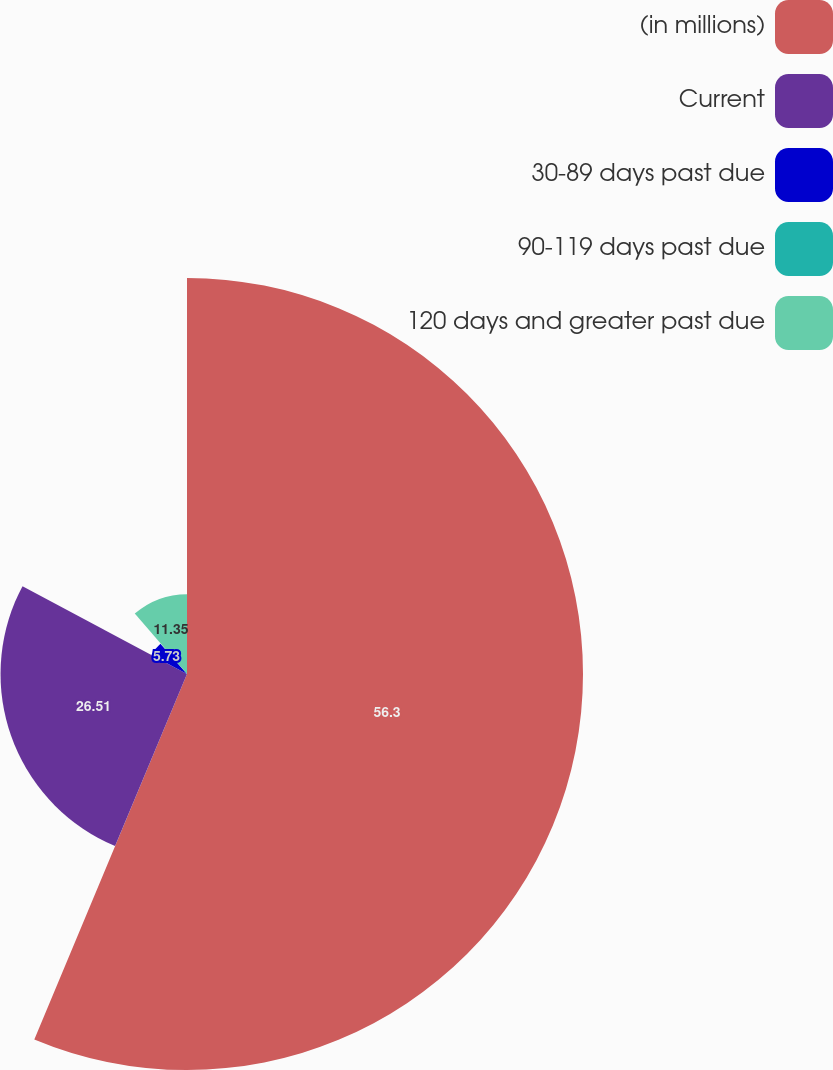<chart> <loc_0><loc_0><loc_500><loc_500><pie_chart><fcel>(in millions)<fcel>Current<fcel>30-89 days past due<fcel>90-119 days past due<fcel>120 days and greater past due<nl><fcel>56.3%<fcel>26.51%<fcel>5.73%<fcel>0.11%<fcel>11.35%<nl></chart> 